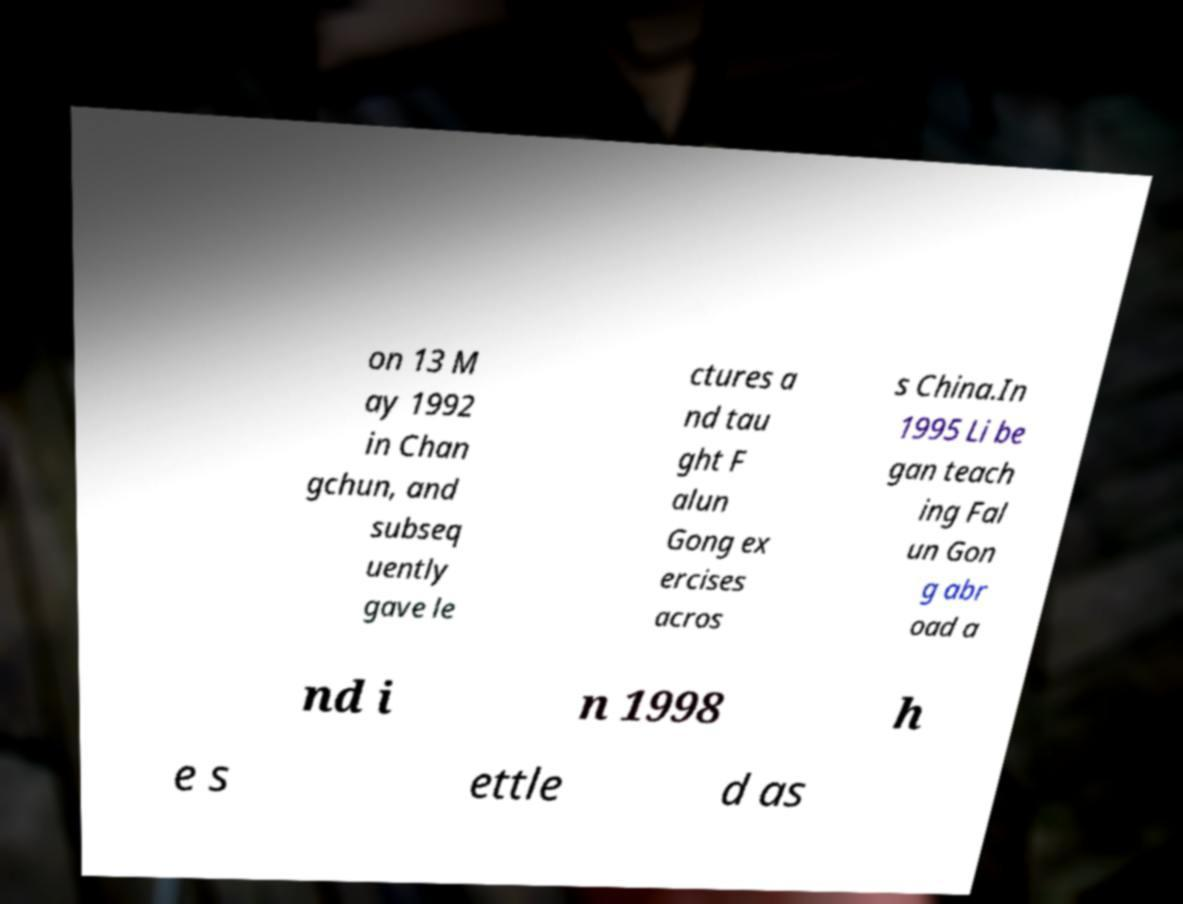Can you accurately transcribe the text from the provided image for me? on 13 M ay 1992 in Chan gchun, and subseq uently gave le ctures a nd tau ght F alun Gong ex ercises acros s China.In 1995 Li be gan teach ing Fal un Gon g abr oad a nd i n 1998 h e s ettle d as 